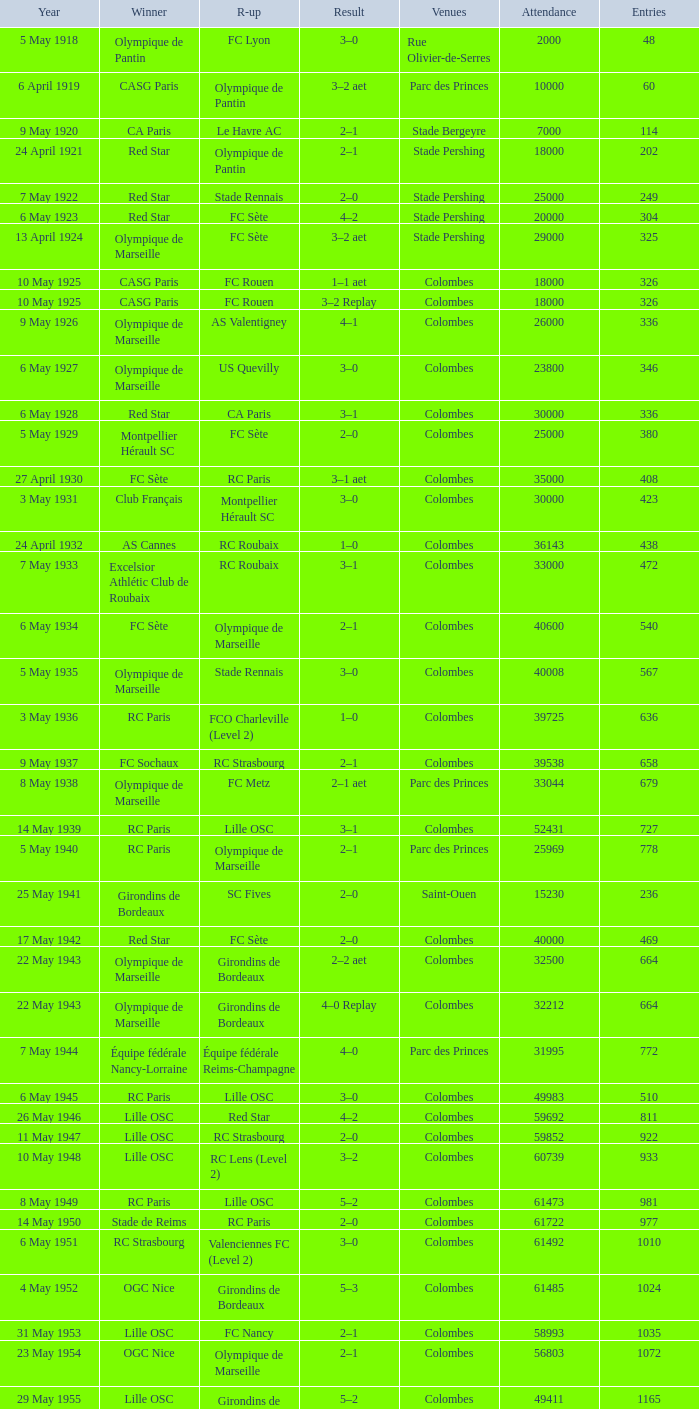What is the fewest recorded entrants against paris saint-germain? 6394.0. 